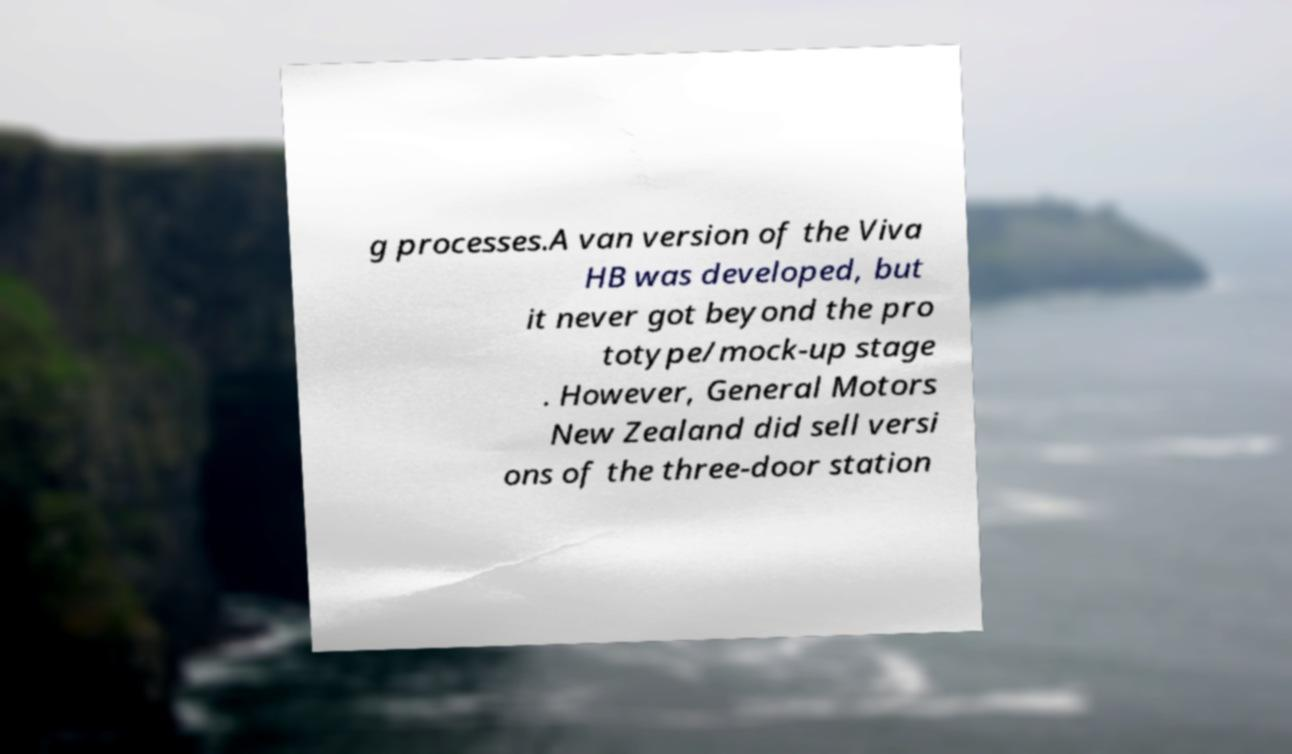What messages or text are displayed in this image? I need them in a readable, typed format. g processes.A van version of the Viva HB was developed, but it never got beyond the pro totype/mock-up stage . However, General Motors New Zealand did sell versi ons of the three-door station 